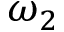Convert formula to latex. <formula><loc_0><loc_0><loc_500><loc_500>\omega _ { 2 }</formula> 